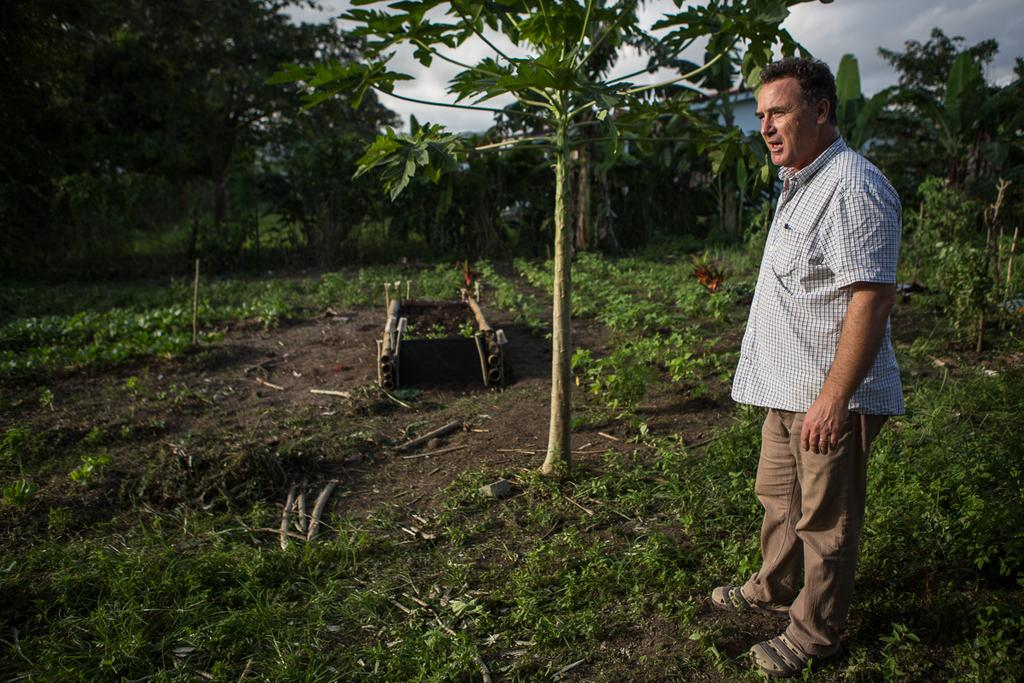Who is present in the image? There is a man in the image. Where is the man located in the image? The man is standing at the right side of the image. What is the man wearing? The man is wearing a shirt and trousers. What type of natural environment is visible in the image? There is grass and trees in the image. How many zippers can be seen on the man's shirt in the image? There is no mention of a zipper on the man's shirt in the image, so it cannot be determined from the facts provided. 